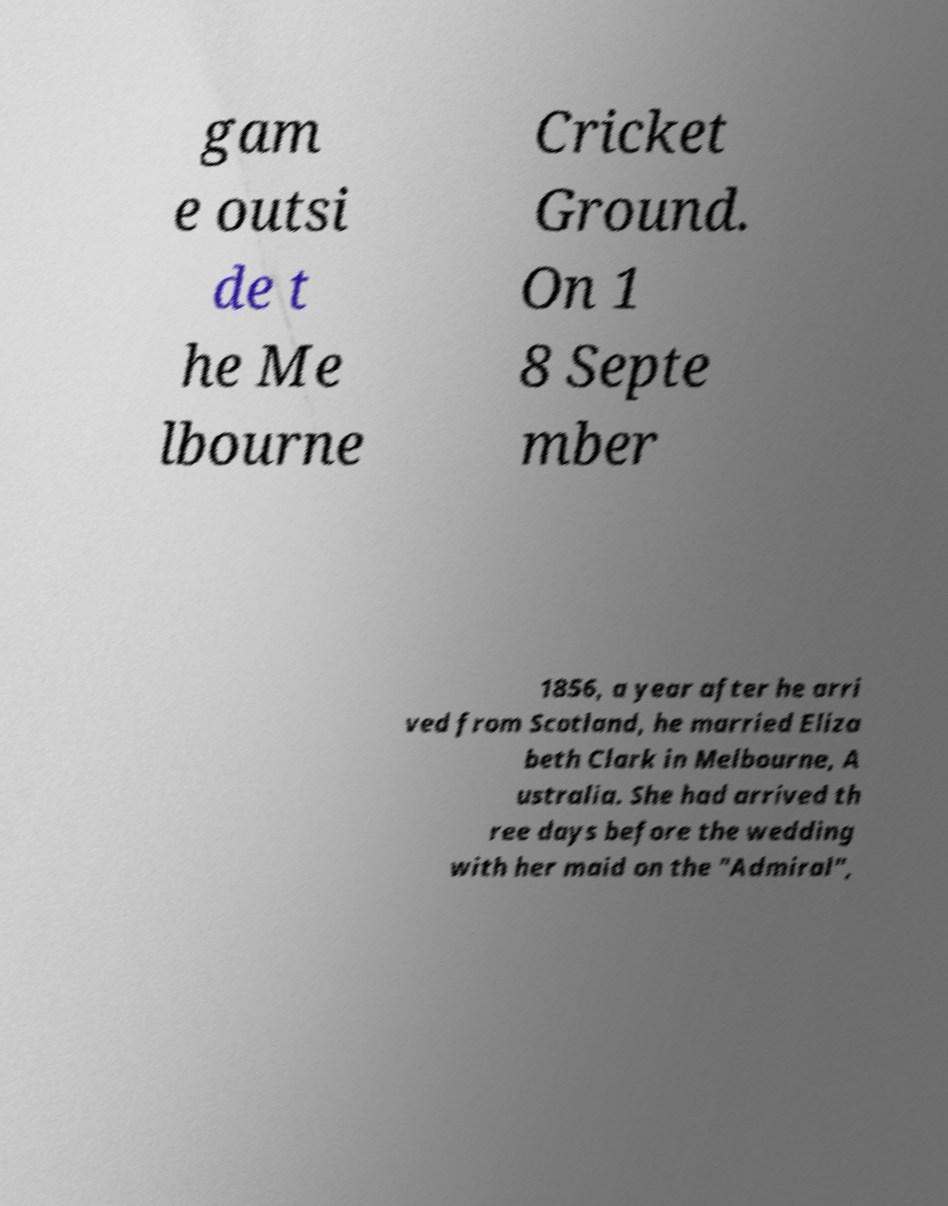Please read and relay the text visible in this image. What does it say? gam e outsi de t he Me lbourne Cricket Ground. On 1 8 Septe mber 1856, a year after he arri ved from Scotland, he married Eliza beth Clark in Melbourne, A ustralia. She had arrived th ree days before the wedding with her maid on the "Admiral", 